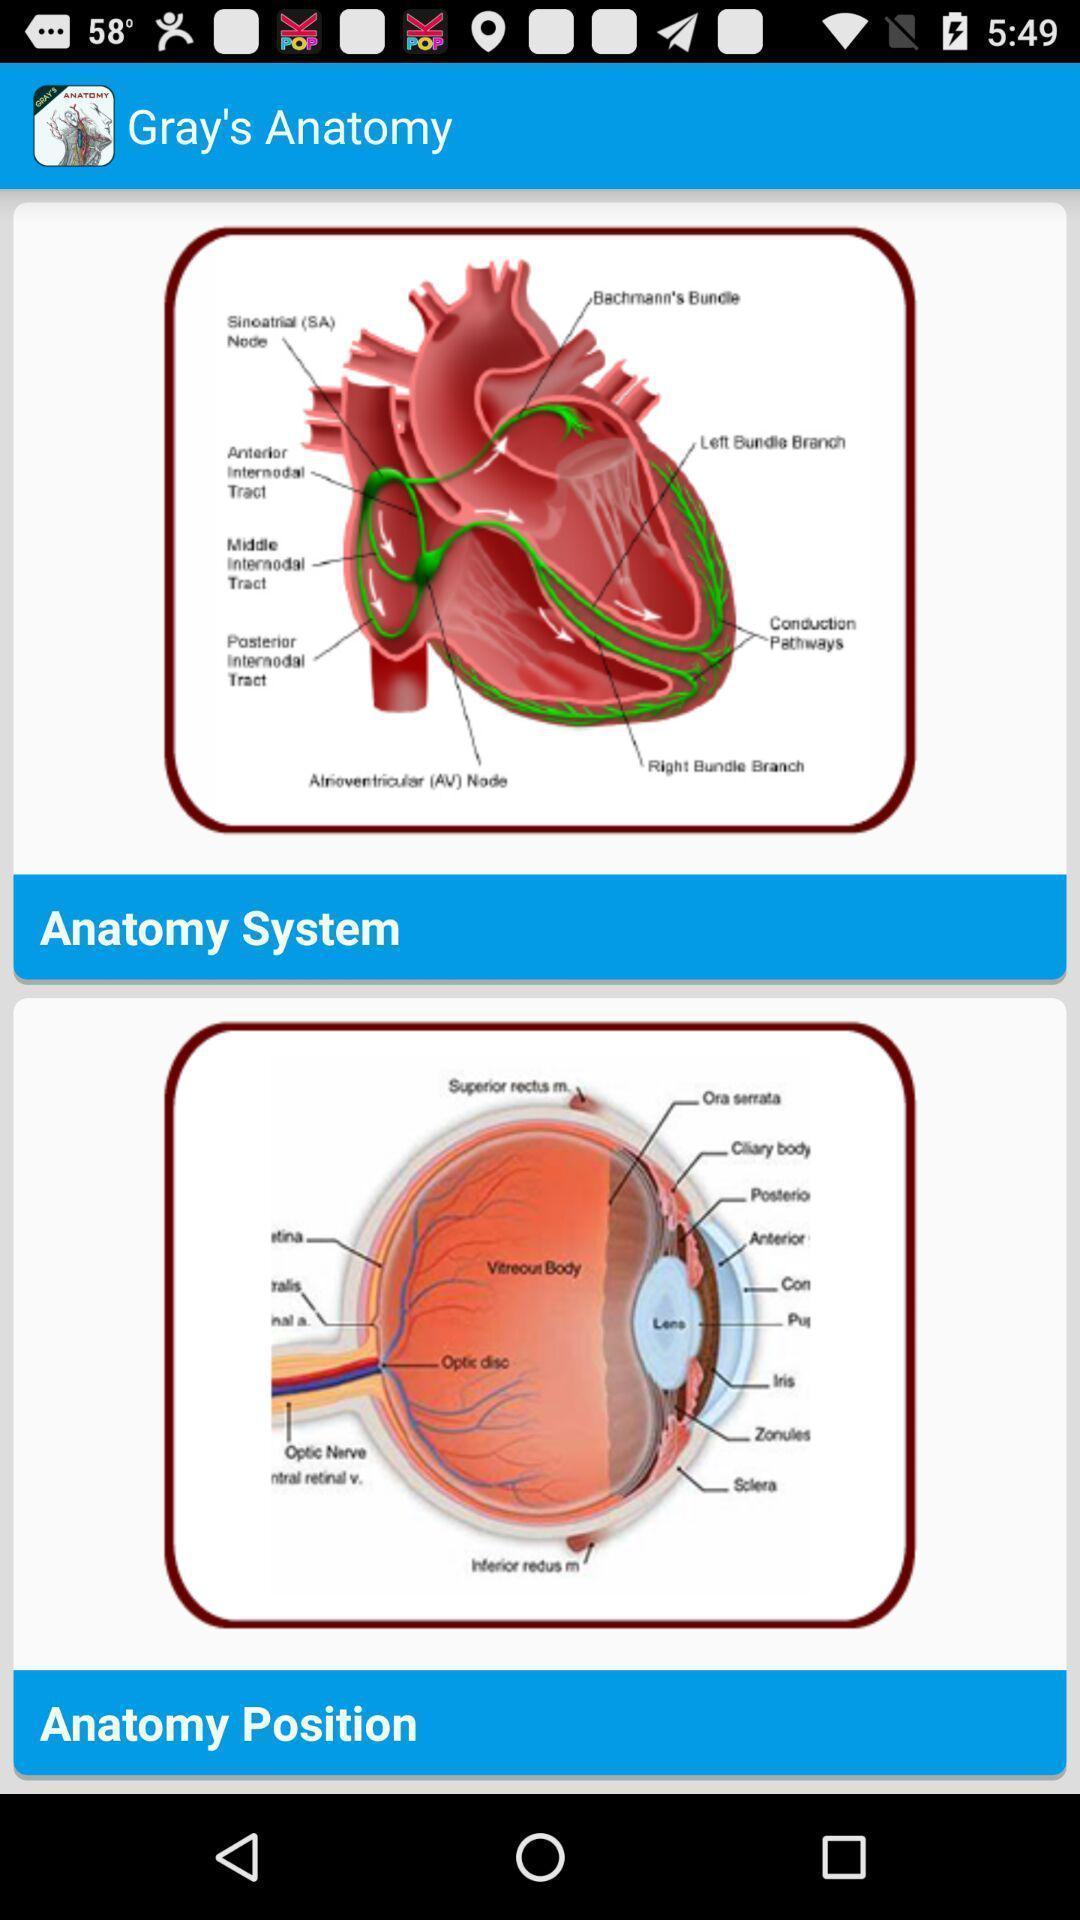Tell me what you see in this picture. Screen showing various anatomy studies. 